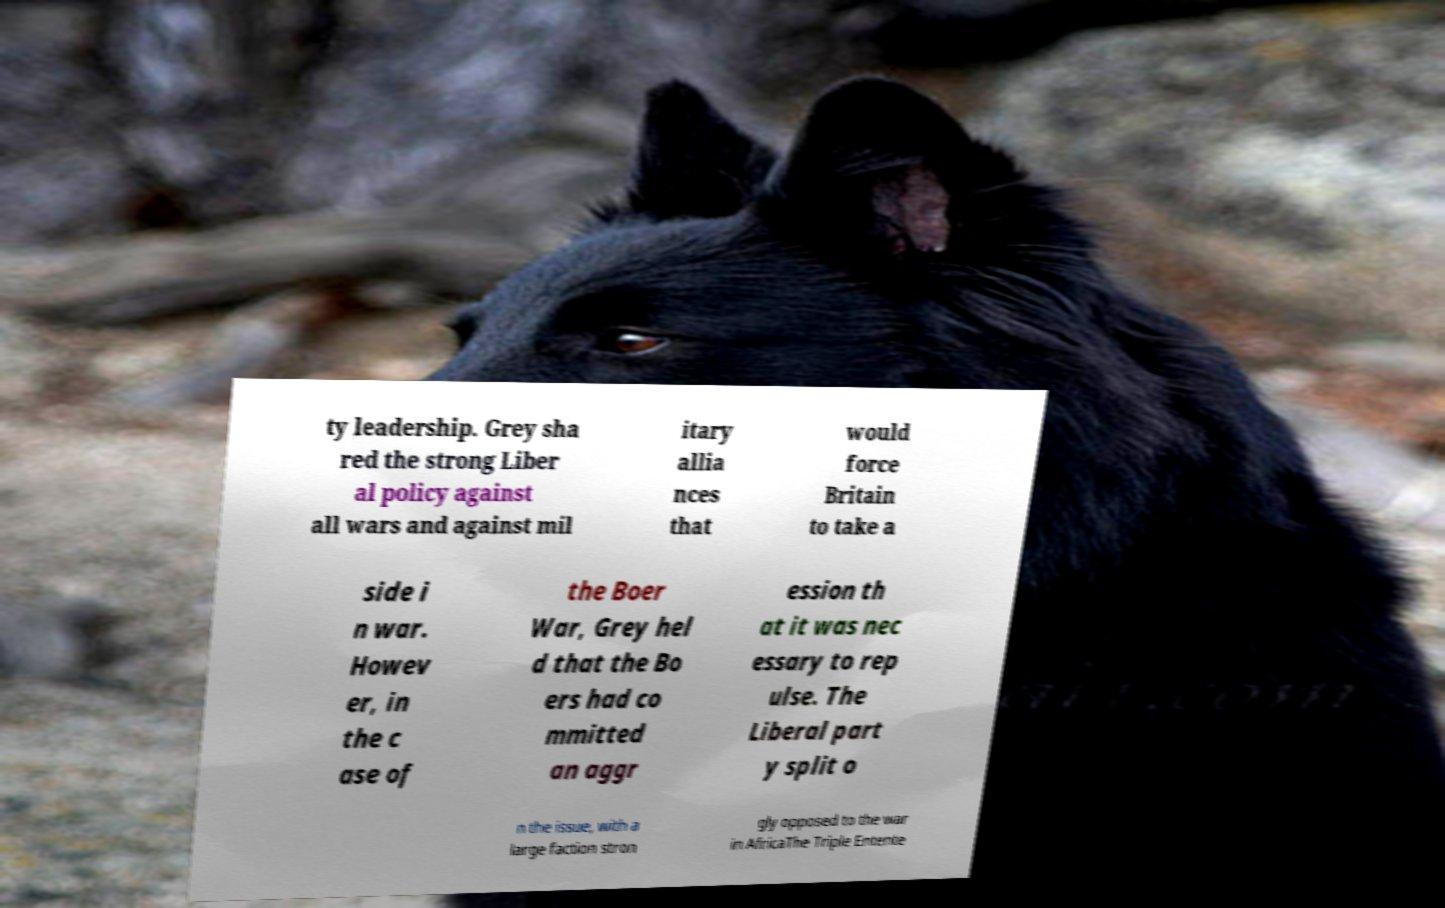Can you read and provide the text displayed in the image?This photo seems to have some interesting text. Can you extract and type it out for me? ty leadership. Grey sha red the strong Liber al policy against all wars and against mil itary allia nces that would force Britain to take a side i n war. Howev er, in the c ase of the Boer War, Grey hel d that the Bo ers had co mmitted an aggr ession th at it was nec essary to rep ulse. The Liberal part y split o n the issue, with a large faction stron gly opposed to the war in AfricaThe Triple Entente 